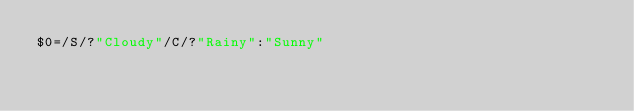<code> <loc_0><loc_0><loc_500><loc_500><_Awk_>$0=/S/?"Cloudy"/C/?"Rainy":"Sunny"</code> 